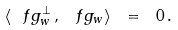Convert formula to latex. <formula><loc_0><loc_0><loc_500><loc_500>\langle { \ f g _ { w } ^ { \perp } } \, , \, \ f g _ { w } \rangle \ = \ 0 \, .</formula> 